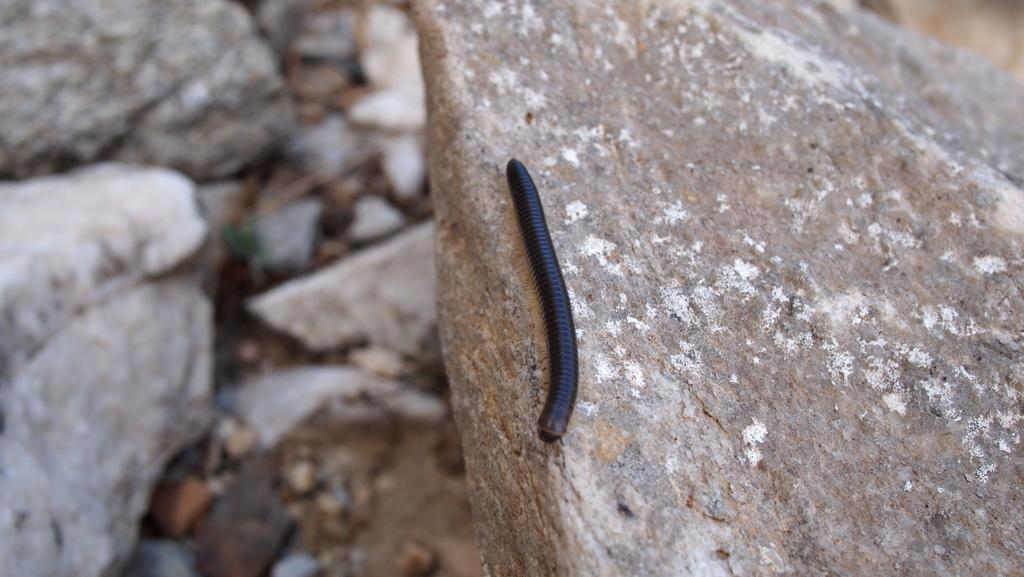What is on the rock in the image? There is an insect on a rock in the image. What else can be seen on the ground in the image? There are rocks on the ground to the left in the image. What type of tree is growing on the rock in the image? There is no tree present in the image; it only features an insect on a rock and rocks on the ground. 